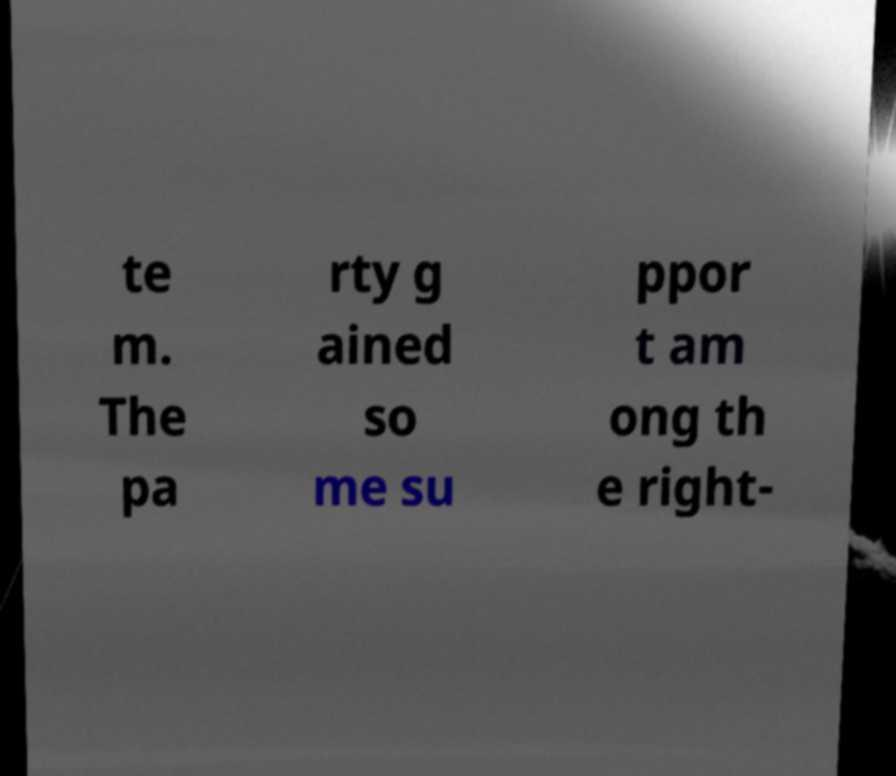Can you read and provide the text displayed in the image?This photo seems to have some interesting text. Can you extract and type it out for me? te m. The pa rty g ained so me su ppor t am ong th e right- 